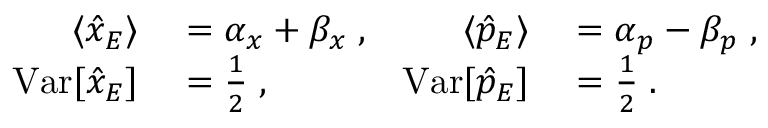<formula> <loc_0><loc_0><loc_500><loc_500>\begin{array} { r l r l } { \langle \hat { x } _ { E } \rangle } & = \alpha _ { x } + \beta _ { x } \, , } & { \langle \hat { p } _ { E } \rangle } & = \alpha _ { p } - \beta _ { p } \, , } \\ { V a r [ \hat { x } _ { E } ] } & = \frac { 1 } { 2 } \, , } & { V a r [ \hat { p } _ { E } ] } & = \frac { 1 } { 2 } \, . } \end{array}</formula> 